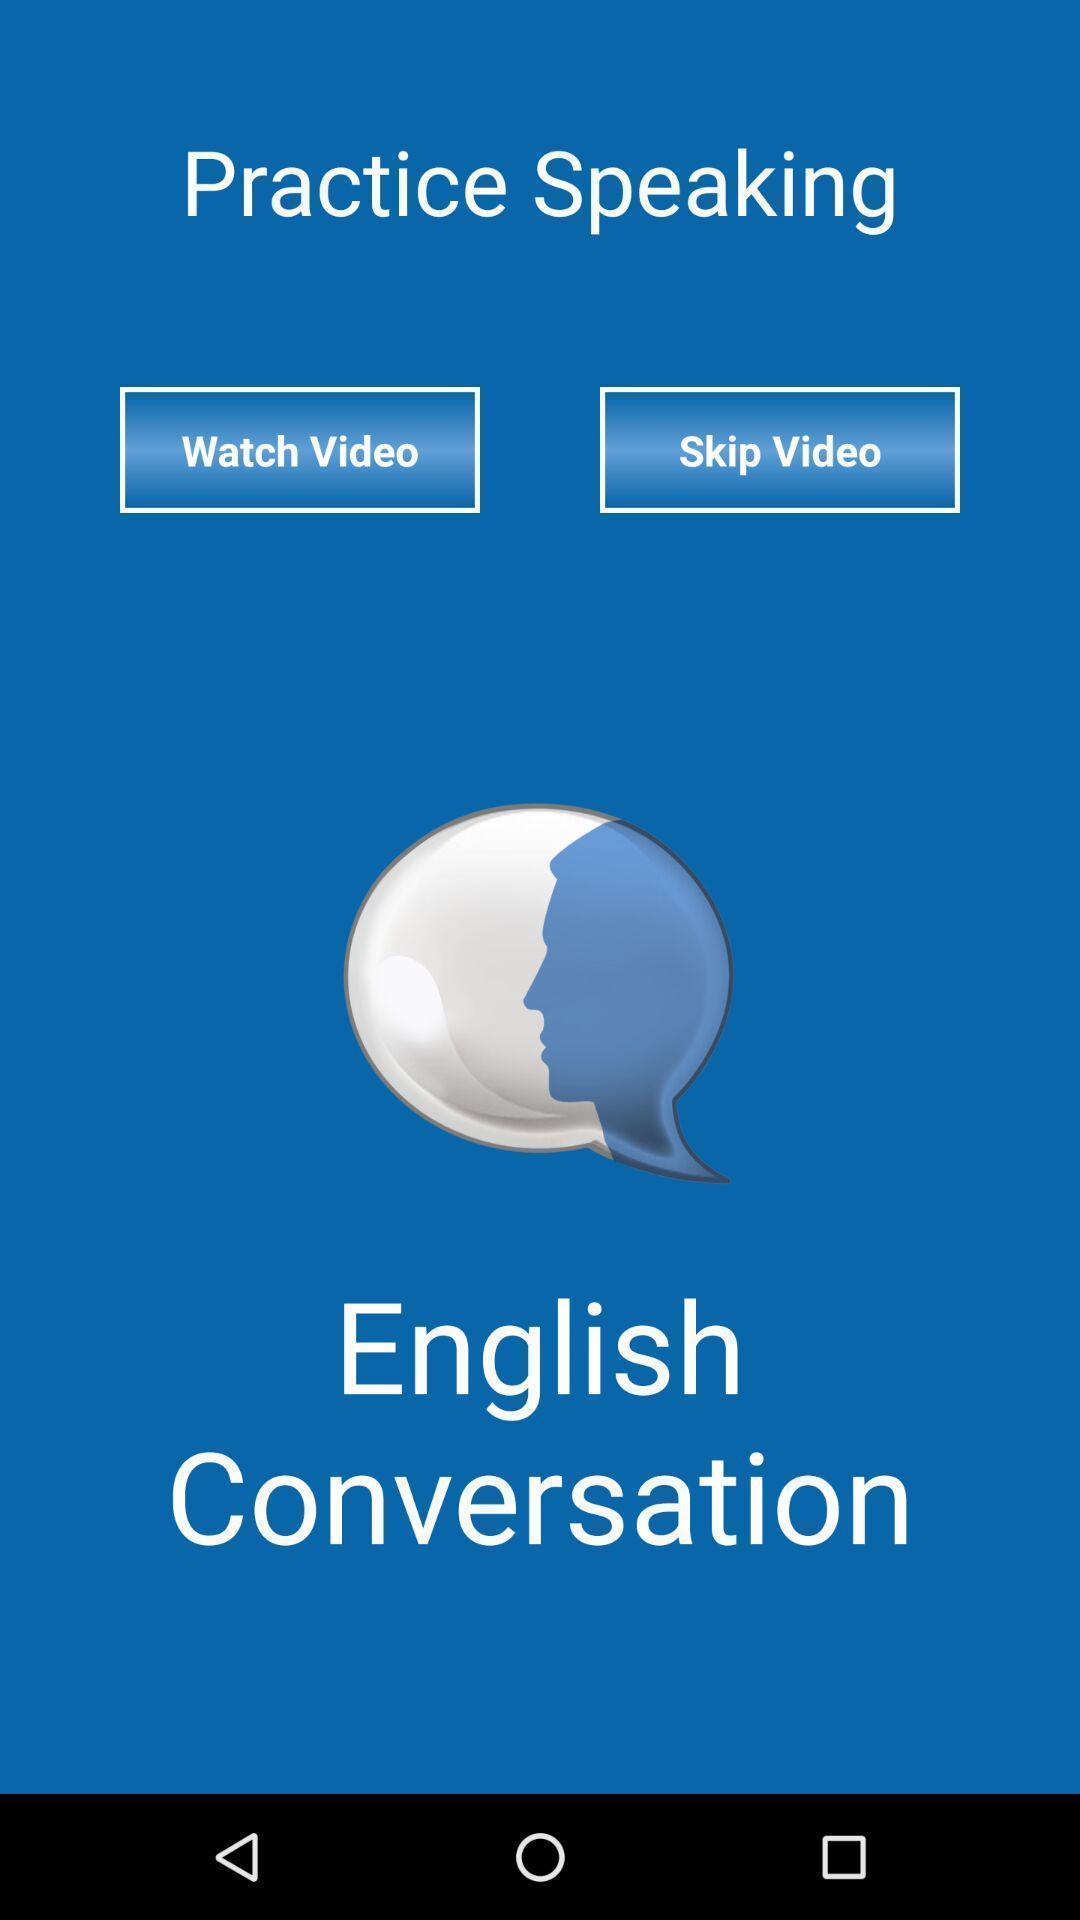Explain what's happening in this screen capture. Welcome page. 